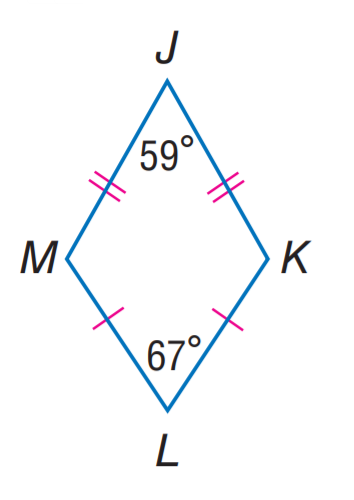Question: Find m \angle K.
Choices:
A. 105
B. 113
C. 117
D. 121
Answer with the letter. Answer: C 